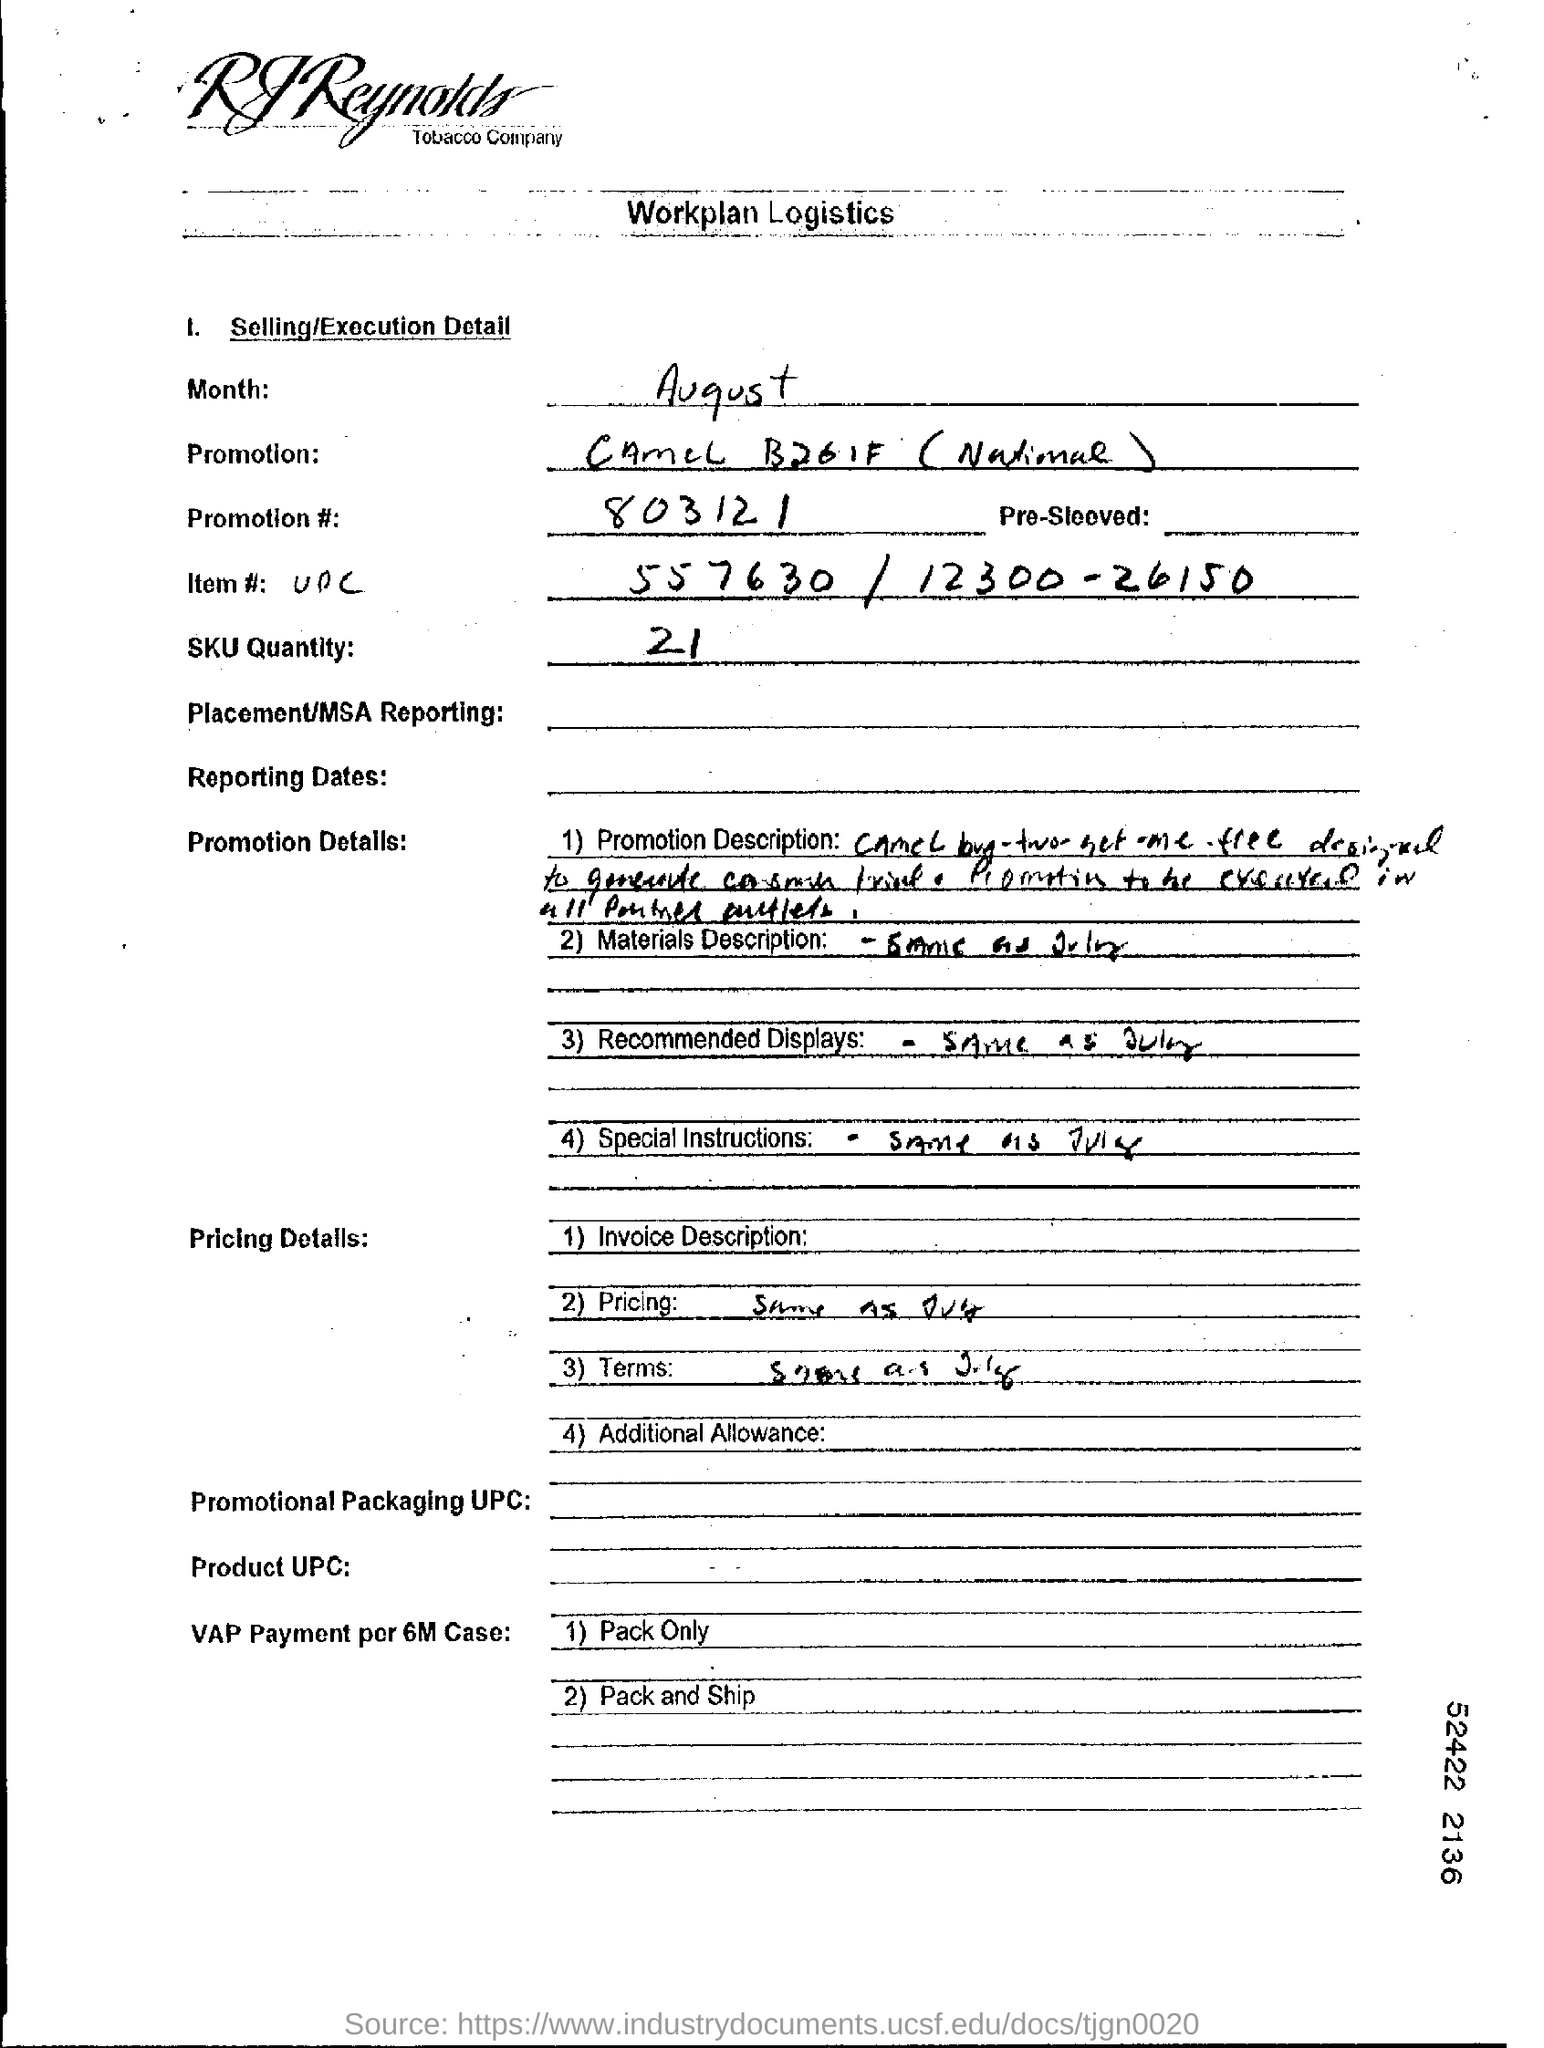What is the promotion number?
Offer a very short reply. 803121. What is the SKU quantity?
Provide a succinct answer. 21. 